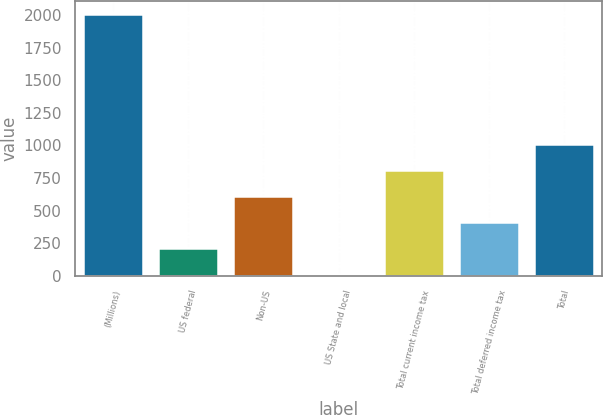Convert chart. <chart><loc_0><loc_0><loc_500><loc_500><bar_chart><fcel>(Millions)<fcel>US federal<fcel>Non-US<fcel>US State and local<fcel>Total current income tax<fcel>Total deferred income tax<fcel>Total<nl><fcel>2010<fcel>214.5<fcel>613.5<fcel>15<fcel>813<fcel>414<fcel>1012.5<nl></chart> 